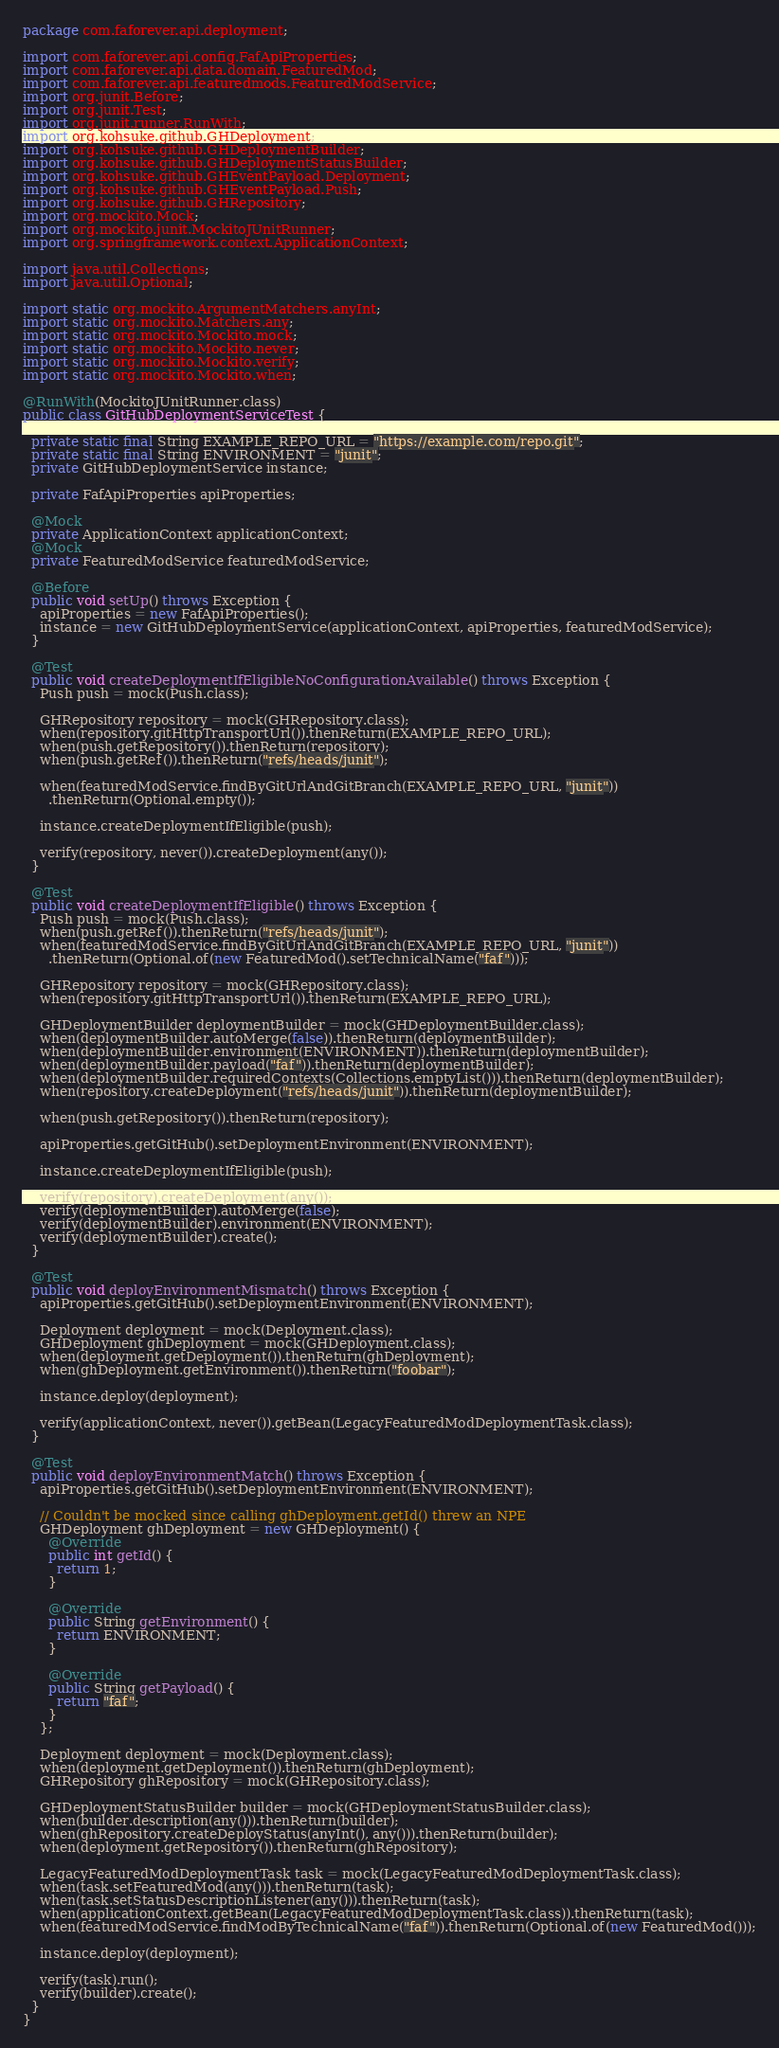<code> <loc_0><loc_0><loc_500><loc_500><_Java_>package com.faforever.api.deployment;

import com.faforever.api.config.FafApiProperties;
import com.faforever.api.data.domain.FeaturedMod;
import com.faforever.api.featuredmods.FeaturedModService;
import org.junit.Before;
import org.junit.Test;
import org.junit.runner.RunWith;
import org.kohsuke.github.GHDeployment;
import org.kohsuke.github.GHDeploymentBuilder;
import org.kohsuke.github.GHDeploymentStatusBuilder;
import org.kohsuke.github.GHEventPayload.Deployment;
import org.kohsuke.github.GHEventPayload.Push;
import org.kohsuke.github.GHRepository;
import org.mockito.Mock;
import org.mockito.junit.MockitoJUnitRunner;
import org.springframework.context.ApplicationContext;

import java.util.Collections;
import java.util.Optional;

import static org.mockito.ArgumentMatchers.anyInt;
import static org.mockito.Matchers.any;
import static org.mockito.Mockito.mock;
import static org.mockito.Mockito.never;
import static org.mockito.Mockito.verify;
import static org.mockito.Mockito.when;

@RunWith(MockitoJUnitRunner.class)
public class GitHubDeploymentServiceTest {

  private static final String EXAMPLE_REPO_URL = "https://example.com/repo.git";
  private static final String ENVIRONMENT = "junit";
  private GitHubDeploymentService instance;

  private FafApiProperties apiProperties;

  @Mock
  private ApplicationContext applicationContext;
  @Mock
  private FeaturedModService featuredModService;

  @Before
  public void setUp() throws Exception {
    apiProperties = new FafApiProperties();
    instance = new GitHubDeploymentService(applicationContext, apiProperties, featuredModService);
  }

  @Test
  public void createDeploymentIfEligibleNoConfigurationAvailable() throws Exception {
    Push push = mock(Push.class);

    GHRepository repository = mock(GHRepository.class);
    when(repository.gitHttpTransportUrl()).thenReturn(EXAMPLE_REPO_URL);
    when(push.getRepository()).thenReturn(repository);
    when(push.getRef()).thenReturn("refs/heads/junit");

    when(featuredModService.findByGitUrlAndGitBranch(EXAMPLE_REPO_URL, "junit"))
      .thenReturn(Optional.empty());

    instance.createDeploymentIfEligible(push);

    verify(repository, never()).createDeployment(any());
  }

  @Test
  public void createDeploymentIfEligible() throws Exception {
    Push push = mock(Push.class);
    when(push.getRef()).thenReturn("refs/heads/junit");
    when(featuredModService.findByGitUrlAndGitBranch(EXAMPLE_REPO_URL, "junit"))
      .thenReturn(Optional.of(new FeaturedMod().setTechnicalName("faf")));

    GHRepository repository = mock(GHRepository.class);
    when(repository.gitHttpTransportUrl()).thenReturn(EXAMPLE_REPO_URL);

    GHDeploymentBuilder deploymentBuilder = mock(GHDeploymentBuilder.class);
    when(deploymentBuilder.autoMerge(false)).thenReturn(deploymentBuilder);
    when(deploymentBuilder.environment(ENVIRONMENT)).thenReturn(deploymentBuilder);
    when(deploymentBuilder.payload("faf")).thenReturn(deploymentBuilder);
    when(deploymentBuilder.requiredContexts(Collections.emptyList())).thenReturn(deploymentBuilder);
    when(repository.createDeployment("refs/heads/junit")).thenReturn(deploymentBuilder);

    when(push.getRepository()).thenReturn(repository);

    apiProperties.getGitHub().setDeploymentEnvironment(ENVIRONMENT);

    instance.createDeploymentIfEligible(push);

    verify(repository).createDeployment(any());
    verify(deploymentBuilder).autoMerge(false);
    verify(deploymentBuilder).environment(ENVIRONMENT);
    verify(deploymentBuilder).create();
  }

  @Test
  public void deployEnvironmentMismatch() throws Exception {
    apiProperties.getGitHub().setDeploymentEnvironment(ENVIRONMENT);

    Deployment deployment = mock(Deployment.class);
    GHDeployment ghDeployment = mock(GHDeployment.class);
    when(deployment.getDeployment()).thenReturn(ghDeployment);
    when(ghDeployment.getEnvironment()).thenReturn("foobar");

    instance.deploy(deployment);

    verify(applicationContext, never()).getBean(LegacyFeaturedModDeploymentTask.class);
  }

  @Test
  public void deployEnvironmentMatch() throws Exception {
    apiProperties.getGitHub().setDeploymentEnvironment(ENVIRONMENT);

    // Couldn't be mocked since calling ghDeployment.getId() threw an NPE
    GHDeployment ghDeployment = new GHDeployment() {
      @Override
      public int getId() {
        return 1;
      }

      @Override
      public String getEnvironment() {
        return ENVIRONMENT;
      }

      @Override
      public String getPayload() {
        return "faf";
      }
    };

    Deployment deployment = mock(Deployment.class);
    when(deployment.getDeployment()).thenReturn(ghDeployment);
    GHRepository ghRepository = mock(GHRepository.class);

    GHDeploymentStatusBuilder builder = mock(GHDeploymentStatusBuilder.class);
    when(builder.description(any())).thenReturn(builder);
    when(ghRepository.createDeployStatus(anyInt(), any())).thenReturn(builder);
    when(deployment.getRepository()).thenReturn(ghRepository);

    LegacyFeaturedModDeploymentTask task = mock(LegacyFeaturedModDeploymentTask.class);
    when(task.setFeaturedMod(any())).thenReturn(task);
    when(task.setStatusDescriptionListener(any())).thenReturn(task);
    when(applicationContext.getBean(LegacyFeaturedModDeploymentTask.class)).thenReturn(task);
    when(featuredModService.findModByTechnicalName("faf")).thenReturn(Optional.of(new FeaturedMod()));

    instance.deploy(deployment);

    verify(task).run();
    verify(builder).create();
  }
}
</code> 